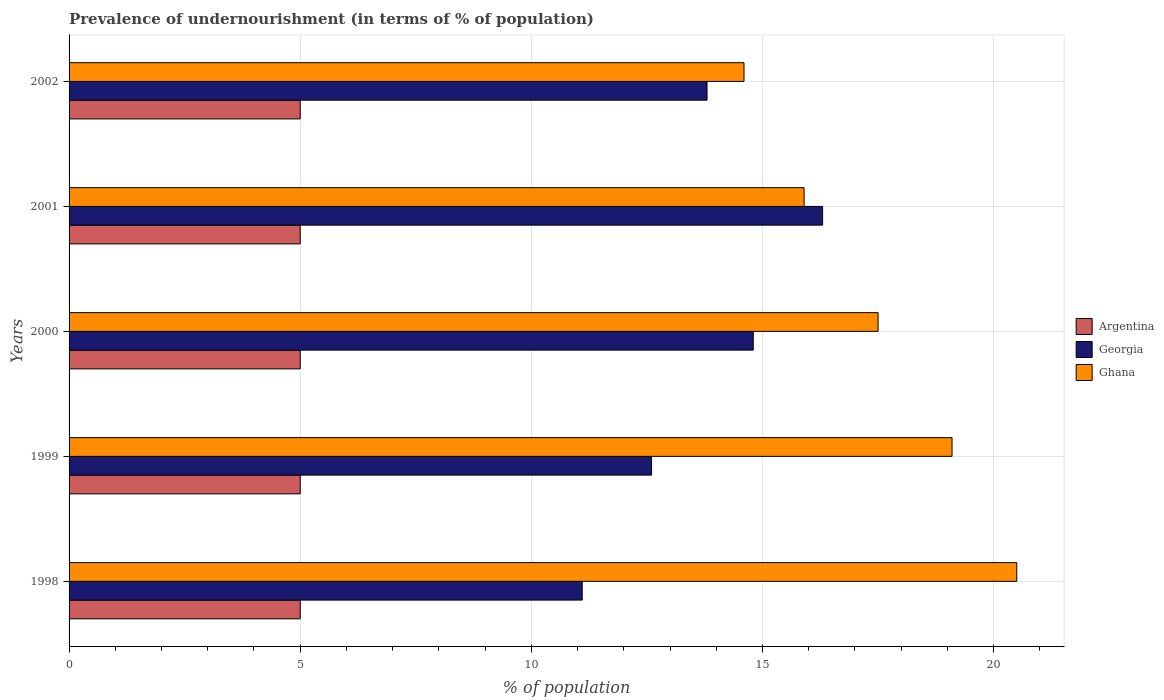How many different coloured bars are there?
Offer a terse response. 3. Are the number of bars per tick equal to the number of legend labels?
Provide a short and direct response. Yes. How many bars are there on the 1st tick from the top?
Your answer should be very brief. 3. How many bars are there on the 2nd tick from the bottom?
Provide a short and direct response. 3. In how many cases, is the number of bars for a given year not equal to the number of legend labels?
Keep it short and to the point. 0. What is the percentage of undernourished population in Georgia in 2001?
Offer a terse response. 16.3. Across all years, what is the minimum percentage of undernourished population in Argentina?
Provide a short and direct response. 5. In which year was the percentage of undernourished population in Argentina maximum?
Ensure brevity in your answer.  1998. In which year was the percentage of undernourished population in Argentina minimum?
Offer a terse response. 1998. What is the total percentage of undernourished population in Ghana in the graph?
Keep it short and to the point. 87.6. What is the difference between the percentage of undernourished population in Georgia in 1999 and that in 2000?
Your response must be concise. -2.2. In the year 1998, what is the difference between the percentage of undernourished population in Ghana and percentage of undernourished population in Argentina?
Provide a succinct answer. 15.5. What is the ratio of the percentage of undernourished population in Georgia in 1998 to that in 2000?
Keep it short and to the point. 0.75. Is the difference between the percentage of undernourished population in Ghana in 2001 and 2002 greater than the difference between the percentage of undernourished population in Argentina in 2001 and 2002?
Give a very brief answer. Yes. What is the difference between the highest and the lowest percentage of undernourished population in Georgia?
Give a very brief answer. 5.2. In how many years, is the percentage of undernourished population in Georgia greater than the average percentage of undernourished population in Georgia taken over all years?
Your answer should be very brief. 3. Is the sum of the percentage of undernourished population in Georgia in 1998 and 2002 greater than the maximum percentage of undernourished population in Ghana across all years?
Provide a succinct answer. Yes. What does the 3rd bar from the top in 2001 represents?
Give a very brief answer. Argentina. What is the difference between two consecutive major ticks on the X-axis?
Your answer should be compact. 5. Are the values on the major ticks of X-axis written in scientific E-notation?
Keep it short and to the point. No. Does the graph contain any zero values?
Ensure brevity in your answer.  No. Where does the legend appear in the graph?
Keep it short and to the point. Center right. How are the legend labels stacked?
Make the answer very short. Vertical. What is the title of the graph?
Give a very brief answer. Prevalence of undernourishment (in terms of % of population). What is the label or title of the X-axis?
Make the answer very short. % of population. What is the label or title of the Y-axis?
Your answer should be compact. Years. What is the % of population of Argentina in 1998?
Ensure brevity in your answer.  5. What is the % of population in Argentina in 1999?
Offer a very short reply. 5. What is the % of population in Argentina in 2000?
Give a very brief answer. 5. What is the % of population of Georgia in 2000?
Give a very brief answer. 14.8. What is the % of population in Ghana in 2000?
Your answer should be compact. 17.5. What is the % of population of Georgia in 2001?
Your response must be concise. 16.3. What is the % of population of Ghana in 2001?
Your answer should be compact. 15.9. What is the % of population of Argentina in 2002?
Offer a terse response. 5. What is the % of population of Georgia in 2002?
Ensure brevity in your answer.  13.8. What is the % of population in Ghana in 2002?
Your response must be concise. 14.6. Across all years, what is the minimum % of population in Ghana?
Your response must be concise. 14.6. What is the total % of population of Argentina in the graph?
Your answer should be very brief. 25. What is the total % of population in Georgia in the graph?
Make the answer very short. 68.6. What is the total % of population of Ghana in the graph?
Provide a succinct answer. 87.6. What is the difference between the % of population in Ghana in 1998 and that in 1999?
Give a very brief answer. 1.4. What is the difference between the % of population of Argentina in 1998 and that in 2000?
Keep it short and to the point. 0. What is the difference between the % of population of Argentina in 1998 and that in 2001?
Your answer should be compact. 0. What is the difference between the % of population of Ghana in 1998 and that in 2001?
Provide a short and direct response. 4.6. What is the difference between the % of population in Ghana in 1998 and that in 2002?
Your answer should be very brief. 5.9. What is the difference between the % of population of Georgia in 1999 and that in 2001?
Provide a succinct answer. -3.7. What is the difference between the % of population in Georgia in 1999 and that in 2002?
Keep it short and to the point. -1.2. What is the difference between the % of population in Argentina in 2000 and that in 2001?
Make the answer very short. 0. What is the difference between the % of population in Ghana in 2000 and that in 2001?
Offer a terse response. 1.6. What is the difference between the % of population in Georgia in 2000 and that in 2002?
Provide a short and direct response. 1. What is the difference between the % of population of Argentina in 1998 and the % of population of Georgia in 1999?
Give a very brief answer. -7.6. What is the difference between the % of population in Argentina in 1998 and the % of population in Ghana in 1999?
Your answer should be very brief. -14.1. What is the difference between the % of population in Argentina in 1998 and the % of population in Georgia in 2000?
Your answer should be compact. -9.8. What is the difference between the % of population in Georgia in 1998 and the % of population in Ghana in 2000?
Offer a very short reply. -6.4. What is the difference between the % of population in Argentina in 1998 and the % of population in Georgia in 2001?
Make the answer very short. -11.3. What is the difference between the % of population of Argentina in 1998 and the % of population of Ghana in 2001?
Provide a short and direct response. -10.9. What is the difference between the % of population in Argentina in 1998 and the % of population in Georgia in 2002?
Your answer should be compact. -8.8. What is the difference between the % of population of Argentina in 1998 and the % of population of Ghana in 2002?
Your answer should be very brief. -9.6. What is the difference between the % of population of Argentina in 1999 and the % of population of Georgia in 2000?
Offer a very short reply. -9.8. What is the difference between the % of population of Argentina in 1999 and the % of population of Georgia in 2001?
Offer a very short reply. -11.3. What is the difference between the % of population of Argentina in 2000 and the % of population of Georgia in 2001?
Your answer should be very brief. -11.3. What is the difference between the % of population in Argentina in 2000 and the % of population in Ghana in 2001?
Ensure brevity in your answer.  -10.9. What is the difference between the % of population in Georgia in 2000 and the % of population in Ghana in 2001?
Your answer should be very brief. -1.1. What is the difference between the % of population in Georgia in 2000 and the % of population in Ghana in 2002?
Your answer should be very brief. 0.2. What is the difference between the % of population in Argentina in 2001 and the % of population in Georgia in 2002?
Ensure brevity in your answer.  -8.8. What is the difference between the % of population in Georgia in 2001 and the % of population in Ghana in 2002?
Provide a short and direct response. 1.7. What is the average % of population of Georgia per year?
Keep it short and to the point. 13.72. What is the average % of population of Ghana per year?
Offer a very short reply. 17.52. In the year 1998, what is the difference between the % of population of Argentina and % of population of Ghana?
Provide a short and direct response. -15.5. In the year 1999, what is the difference between the % of population of Argentina and % of population of Ghana?
Provide a short and direct response. -14.1. In the year 1999, what is the difference between the % of population in Georgia and % of population in Ghana?
Ensure brevity in your answer.  -6.5. In the year 2000, what is the difference between the % of population of Georgia and % of population of Ghana?
Give a very brief answer. -2.7. In the year 2001, what is the difference between the % of population in Argentina and % of population in Georgia?
Make the answer very short. -11.3. What is the ratio of the % of population of Georgia in 1998 to that in 1999?
Offer a very short reply. 0.88. What is the ratio of the % of population in Ghana in 1998 to that in 1999?
Offer a very short reply. 1.07. What is the ratio of the % of population in Ghana in 1998 to that in 2000?
Your answer should be compact. 1.17. What is the ratio of the % of population in Argentina in 1998 to that in 2001?
Your response must be concise. 1. What is the ratio of the % of population of Georgia in 1998 to that in 2001?
Keep it short and to the point. 0.68. What is the ratio of the % of population of Ghana in 1998 to that in 2001?
Your response must be concise. 1.29. What is the ratio of the % of population of Argentina in 1998 to that in 2002?
Your answer should be very brief. 1. What is the ratio of the % of population of Georgia in 1998 to that in 2002?
Your answer should be compact. 0.8. What is the ratio of the % of population of Ghana in 1998 to that in 2002?
Your response must be concise. 1.4. What is the ratio of the % of population of Georgia in 1999 to that in 2000?
Your response must be concise. 0.85. What is the ratio of the % of population in Ghana in 1999 to that in 2000?
Provide a succinct answer. 1.09. What is the ratio of the % of population of Argentina in 1999 to that in 2001?
Give a very brief answer. 1. What is the ratio of the % of population in Georgia in 1999 to that in 2001?
Provide a succinct answer. 0.77. What is the ratio of the % of population of Ghana in 1999 to that in 2001?
Give a very brief answer. 1.2. What is the ratio of the % of population of Georgia in 1999 to that in 2002?
Make the answer very short. 0.91. What is the ratio of the % of population of Ghana in 1999 to that in 2002?
Offer a terse response. 1.31. What is the ratio of the % of population in Georgia in 2000 to that in 2001?
Give a very brief answer. 0.91. What is the ratio of the % of population of Ghana in 2000 to that in 2001?
Offer a very short reply. 1.1. What is the ratio of the % of population in Georgia in 2000 to that in 2002?
Give a very brief answer. 1.07. What is the ratio of the % of population in Ghana in 2000 to that in 2002?
Offer a terse response. 1.2. What is the ratio of the % of population in Argentina in 2001 to that in 2002?
Provide a short and direct response. 1. What is the ratio of the % of population of Georgia in 2001 to that in 2002?
Your answer should be compact. 1.18. What is the ratio of the % of population of Ghana in 2001 to that in 2002?
Your answer should be very brief. 1.09. What is the difference between the highest and the second highest % of population in Ghana?
Ensure brevity in your answer.  1.4. What is the difference between the highest and the lowest % of population of Argentina?
Give a very brief answer. 0. What is the difference between the highest and the lowest % of population of Ghana?
Provide a short and direct response. 5.9. 